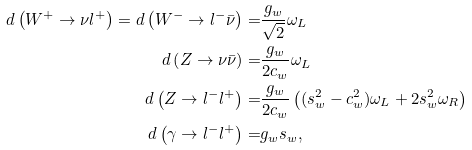Convert formula to latex. <formula><loc_0><loc_0><loc_500><loc_500>d \left ( W ^ { + } \to \nu l ^ { + } \right ) = d \left ( W ^ { - } \to l ^ { - } \bar { \nu } \right ) = & \frac { g _ { w } } { \sqrt { 2 } } \omega _ { L } \\ d \left ( Z \to \nu \bar { \nu } \right ) = & \frac { g _ { w } } { 2 c _ { w } } \omega _ { L } \\ d \left ( Z \to l ^ { - } l ^ { + } \right ) = & \frac { g _ { w } } { 2 c _ { w } } \left ( ( s _ { w } ^ { 2 } - c _ { w } ^ { 2 } ) \omega _ { L } + 2 s _ { w } ^ { 2 } \omega _ { R } \right ) \\ d \left ( \gamma \to l ^ { - } l ^ { + } \right ) = & g _ { w } s _ { w } ,</formula> 